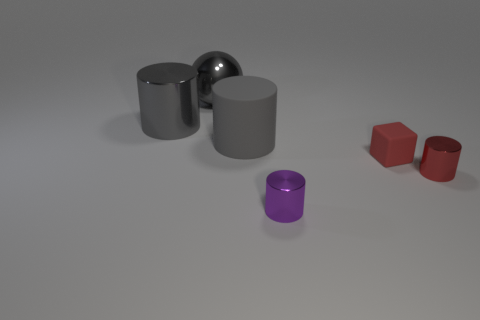Subtract all metallic cylinders. How many cylinders are left? 1 Subtract all green blocks. How many gray cylinders are left? 2 Add 4 purple metal things. How many objects exist? 10 Subtract all red cylinders. How many cylinders are left? 3 Subtract all spheres. How many objects are left? 5 Subtract all blue cylinders. Subtract all yellow cubes. How many cylinders are left? 4 Add 3 small purple shiny cylinders. How many small purple shiny cylinders are left? 4 Add 3 gray rubber objects. How many gray rubber objects exist? 4 Subtract 0 blue cylinders. How many objects are left? 6 Subtract all blue shiny objects. Subtract all purple things. How many objects are left? 5 